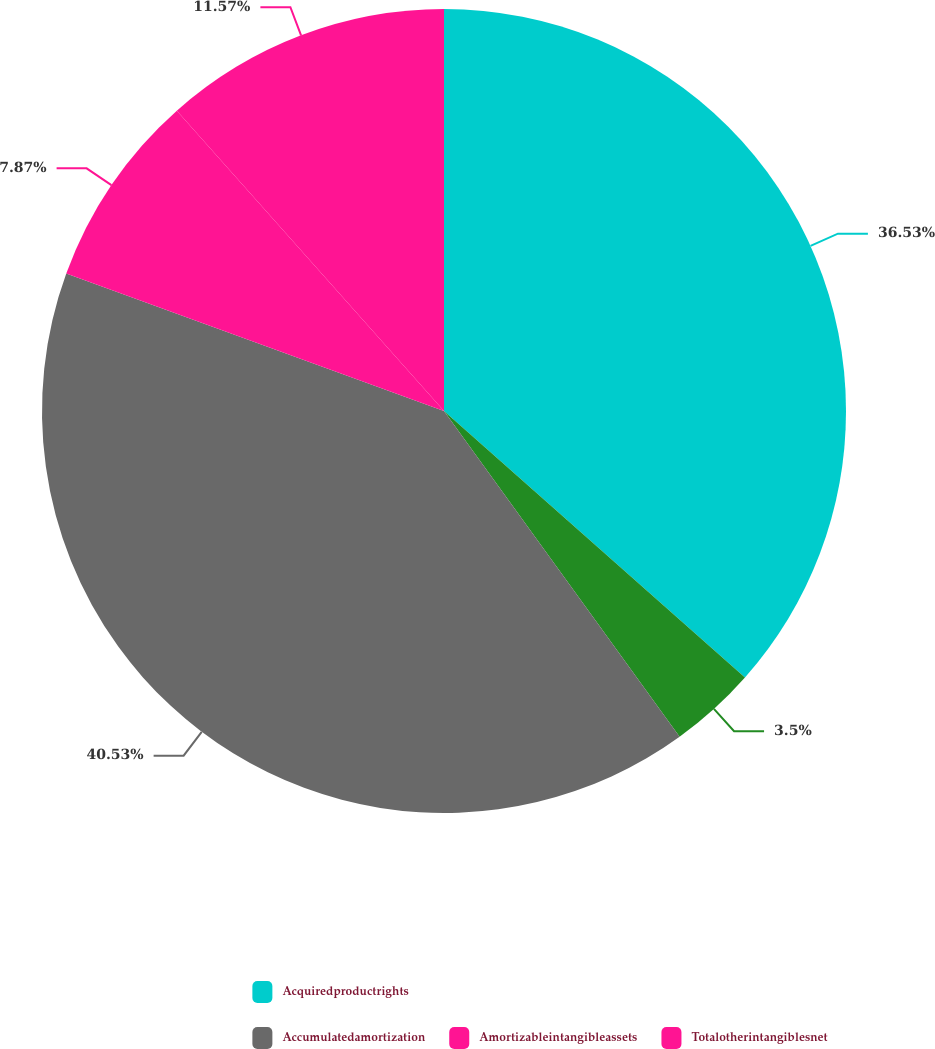<chart> <loc_0><loc_0><loc_500><loc_500><pie_chart><fcel>Acquiredproductrights<fcel>Unnamed: 1<fcel>Accumulatedamortization<fcel>Amortizableintangibleassets<fcel>Totalotherintangiblesnet<nl><fcel>36.53%<fcel>3.5%<fcel>40.52%<fcel>7.87%<fcel>11.57%<nl></chart> 